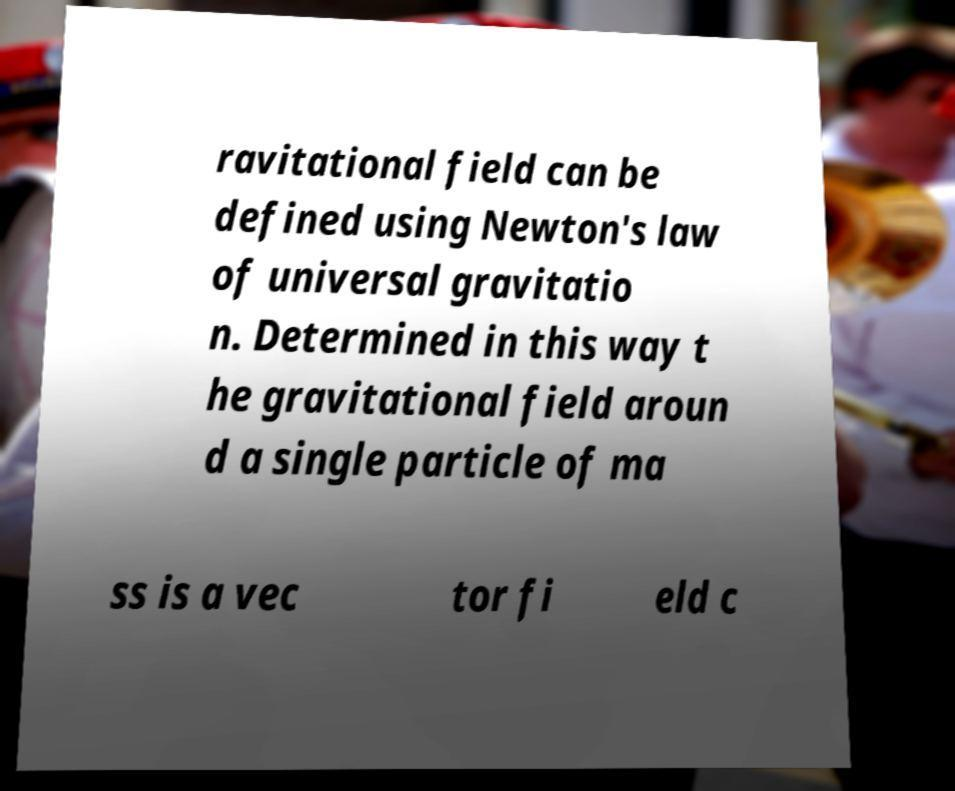For documentation purposes, I need the text within this image transcribed. Could you provide that? ravitational field can be defined using Newton's law of universal gravitatio n. Determined in this way t he gravitational field aroun d a single particle of ma ss is a vec tor fi eld c 